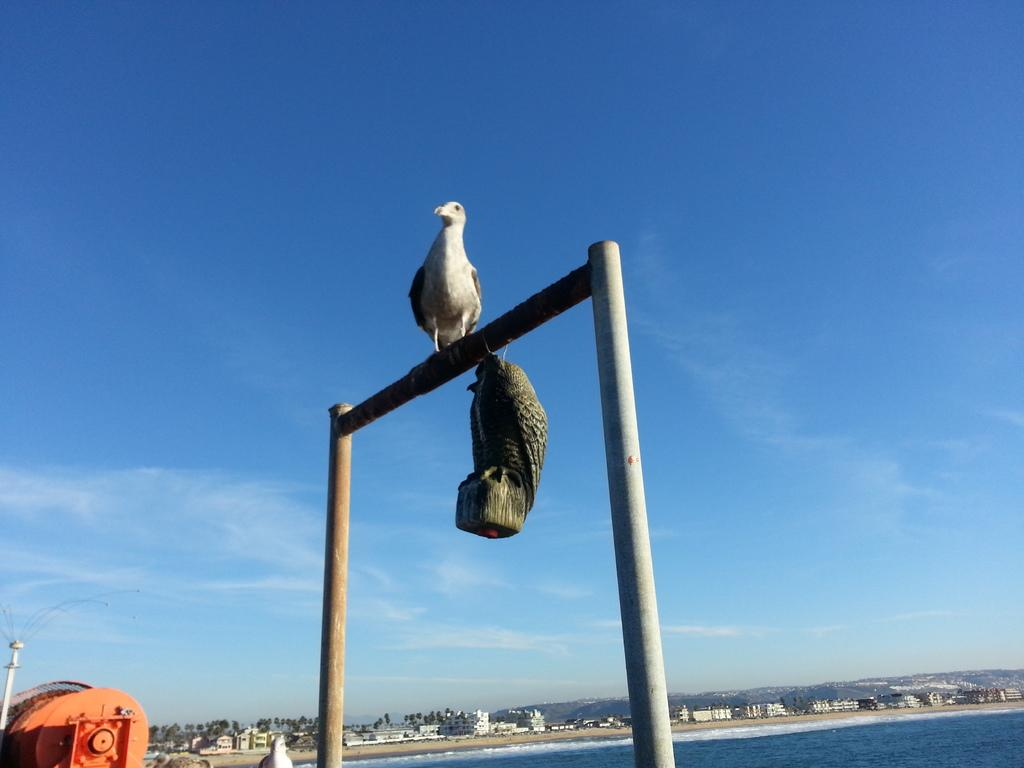What is on the pole stand in the image? There is a bird on the pole stand in the image. What can be seen in the background of the image? Water, sand, buildings, trees, metal objects, and clouds are visible in the background of the image. How many pins can be seen on the bird in the image? There are no pins visible on the bird in the image. What type of bean is growing near the bird in the image? There are no beans present in the image. 